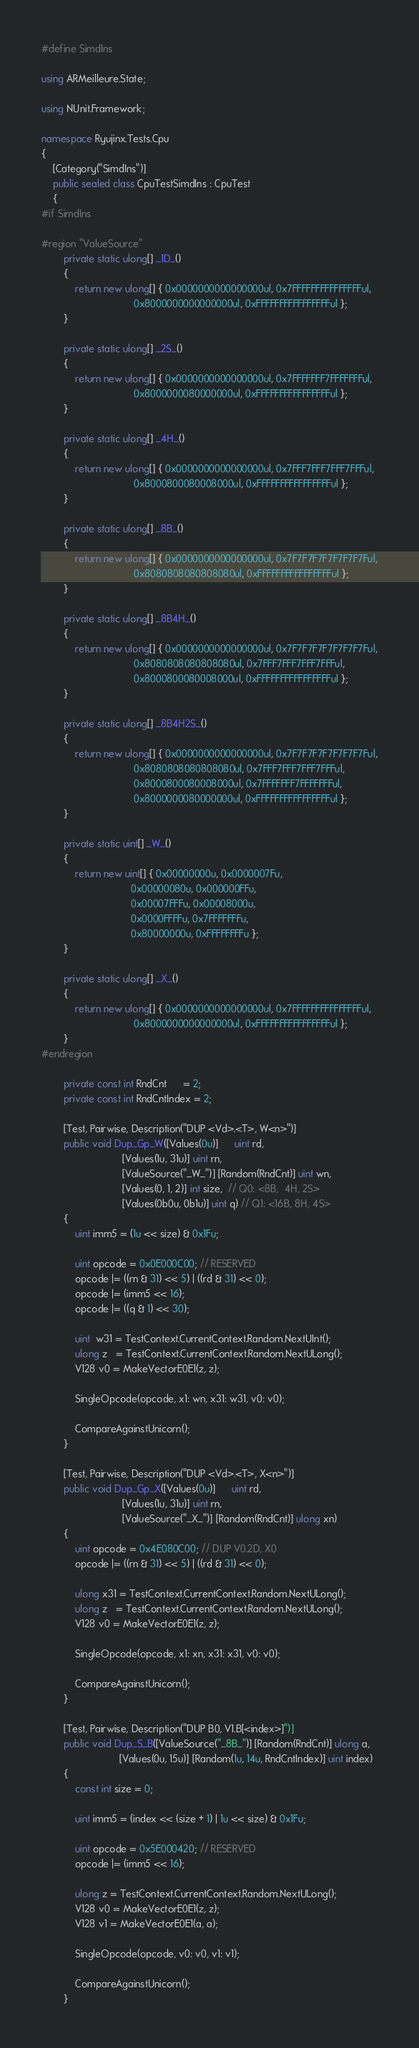<code> <loc_0><loc_0><loc_500><loc_500><_C#_>#define SimdIns

using ARMeilleure.State;

using NUnit.Framework;

namespace Ryujinx.Tests.Cpu
{
    [Category("SimdIns")]
    public sealed class CpuTestSimdIns : CpuTest
    {
#if SimdIns

#region "ValueSource"
        private static ulong[] _1D_()
        {
            return new ulong[] { 0x0000000000000000ul, 0x7FFFFFFFFFFFFFFFul,
                                 0x8000000000000000ul, 0xFFFFFFFFFFFFFFFFul };
        }

        private static ulong[] _2S_()
        {
            return new ulong[] { 0x0000000000000000ul, 0x7FFFFFFF7FFFFFFFul,
                                 0x8000000080000000ul, 0xFFFFFFFFFFFFFFFFul };
        }

        private static ulong[] _4H_()
        {
            return new ulong[] { 0x0000000000000000ul, 0x7FFF7FFF7FFF7FFFul,
                                 0x8000800080008000ul, 0xFFFFFFFFFFFFFFFFul };
        }

        private static ulong[] _8B_()
        {
            return new ulong[] { 0x0000000000000000ul, 0x7F7F7F7F7F7F7F7Ful,
                                 0x8080808080808080ul, 0xFFFFFFFFFFFFFFFFul };
        }

        private static ulong[] _8B4H_()
        {
            return new ulong[] { 0x0000000000000000ul, 0x7F7F7F7F7F7F7F7Ful,
                                 0x8080808080808080ul, 0x7FFF7FFF7FFF7FFFul,
                                 0x8000800080008000ul, 0xFFFFFFFFFFFFFFFFul };
        }

        private static ulong[] _8B4H2S_()
        {
            return new ulong[] { 0x0000000000000000ul, 0x7F7F7F7F7F7F7F7Ful,
                                 0x8080808080808080ul, 0x7FFF7FFF7FFF7FFFul,
                                 0x8000800080008000ul, 0x7FFFFFFF7FFFFFFFul,
                                 0x8000000080000000ul, 0xFFFFFFFFFFFFFFFFul };
        }

        private static uint[] _W_()
        {
            return new uint[] { 0x00000000u, 0x0000007Fu,
                                0x00000080u, 0x000000FFu,
                                0x00007FFFu, 0x00008000u,
                                0x0000FFFFu, 0x7FFFFFFFu,
                                0x80000000u, 0xFFFFFFFFu };
        }

        private static ulong[] _X_()
        {
            return new ulong[] { 0x0000000000000000ul, 0x7FFFFFFFFFFFFFFFul,
                                 0x8000000000000000ul, 0xFFFFFFFFFFFFFFFFul };
        }
#endregion

        private const int RndCnt      = 2;
        private const int RndCntIndex = 2;

        [Test, Pairwise, Description("DUP <Vd>.<T>, W<n>")]
        public void Dup_Gp_W([Values(0u)]      uint rd,
                             [Values(1u, 31u)] uint rn,
                             [ValueSource("_W_")] [Random(RndCnt)] uint wn,
                             [Values(0, 1, 2)] int size,  // Q0: <8B,  4H, 2S>
                             [Values(0b0u, 0b1u)] uint q) // Q1: <16B, 8H, 4S>
        {
            uint imm5 = (1u << size) & 0x1Fu;

            uint opcode = 0x0E000C00; // RESERVED
            opcode |= ((rn & 31) << 5) | ((rd & 31) << 0);
            opcode |= (imm5 << 16);
            opcode |= ((q & 1) << 30);

            uint  w31 = TestContext.CurrentContext.Random.NextUInt();
            ulong z   = TestContext.CurrentContext.Random.NextULong();
            V128 v0 = MakeVectorE0E1(z, z);

            SingleOpcode(opcode, x1: wn, x31: w31, v0: v0);

            CompareAgainstUnicorn();
        }

        [Test, Pairwise, Description("DUP <Vd>.<T>, X<n>")]
        public void Dup_Gp_X([Values(0u)]      uint rd,
                             [Values(1u, 31u)] uint rn,
                             [ValueSource("_X_")] [Random(RndCnt)] ulong xn)
        {
            uint opcode = 0x4E080C00; // DUP V0.2D, X0
            opcode |= ((rn & 31) << 5) | ((rd & 31) << 0);

            ulong x31 = TestContext.CurrentContext.Random.NextULong();
            ulong z   = TestContext.CurrentContext.Random.NextULong();
            V128 v0 = MakeVectorE0E1(z, z);

            SingleOpcode(opcode, x1: xn, x31: x31, v0: v0);

            CompareAgainstUnicorn();
        }

        [Test, Pairwise, Description("DUP B0, V1.B[<index>]")]
        public void Dup_S_B([ValueSource("_8B_")] [Random(RndCnt)] ulong a,
                            [Values(0u, 15u)] [Random(1u, 14u, RndCntIndex)] uint index)
        {
            const int size = 0;

            uint imm5 = (index << (size + 1) | 1u << size) & 0x1Fu;

            uint opcode = 0x5E000420; // RESERVED
            opcode |= (imm5 << 16);

            ulong z = TestContext.CurrentContext.Random.NextULong();
            V128 v0 = MakeVectorE0E1(z, z);
            V128 v1 = MakeVectorE0E1(a, a);

            SingleOpcode(opcode, v0: v0, v1: v1);

            CompareAgainstUnicorn();
        }
</code> 